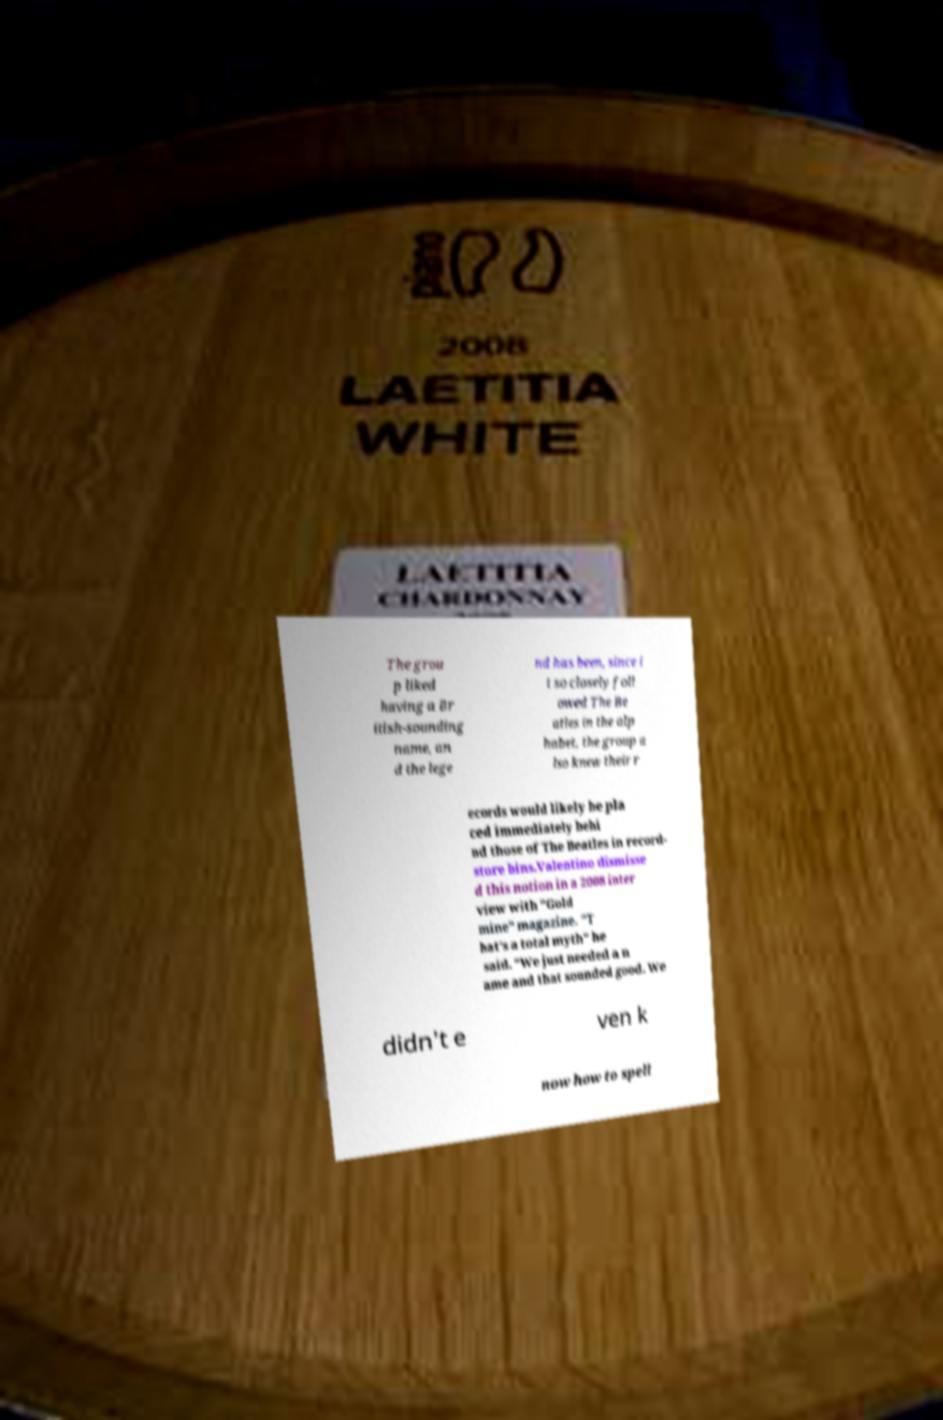Can you read and provide the text displayed in the image?This photo seems to have some interesting text. Can you extract and type it out for me? The grou p liked having a Br itish-sounding name, an d the lege nd has been, since i t so closely foll owed The Be atles in the alp habet, the group a lso knew their r ecords would likely be pla ced immediately behi nd those of The Beatles in record- store bins.Valentino dismisse d this notion in a 2008 inter view with "Gold mine" magazine. "T hat's a total myth" he said. "We just needed a n ame and that sounded good. We didn't e ven k now how to spell 